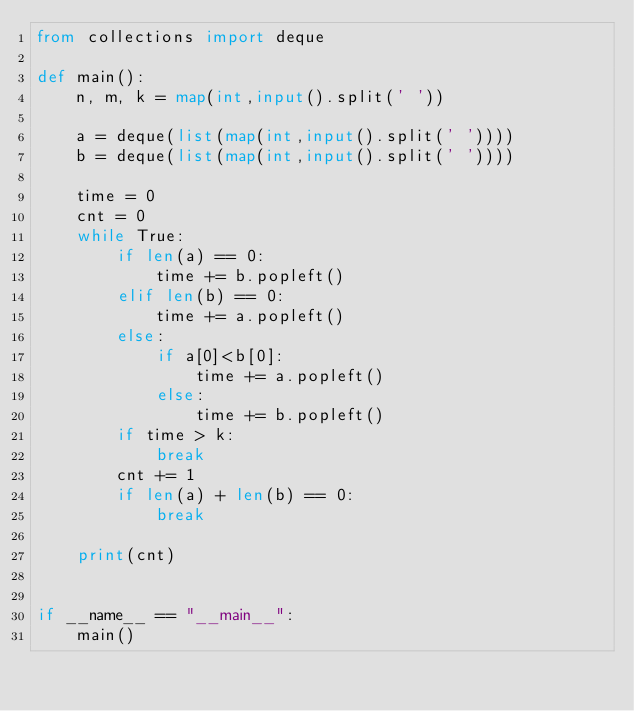Convert code to text. <code><loc_0><loc_0><loc_500><loc_500><_Python_>from collections import deque

def main():
    n, m, k = map(int,input().split(' '))

    a = deque(list(map(int,input().split(' '))))
    b = deque(list(map(int,input().split(' '))))

    time = 0
    cnt = 0
    while True:
        if len(a) == 0:
            time += b.popleft()
        elif len(b) == 0:
            time += a.popleft()
        else:
            if a[0]<b[0]:
                time += a.popleft()
            else:
                time += b.popleft()
        if time > k:
            break
        cnt += 1
        if len(a) + len(b) == 0:
            break
    
    print(cnt)


if __name__ == "__main__":
    main()
</code> 